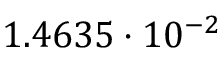Convert formula to latex. <formula><loc_0><loc_0><loc_500><loc_500>1 . 4 6 3 5 \cdot 1 0 ^ { - 2 }</formula> 